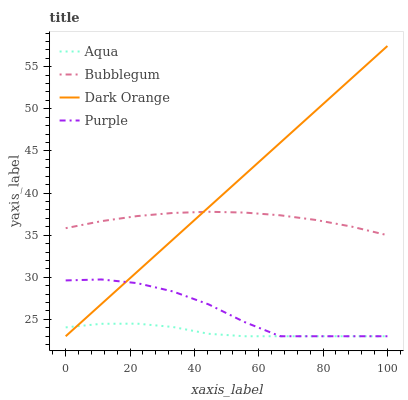Does Aqua have the minimum area under the curve?
Answer yes or no. Yes. Does Dark Orange have the maximum area under the curve?
Answer yes or no. Yes. Does Dark Orange have the minimum area under the curve?
Answer yes or no. No. Does Aqua have the maximum area under the curve?
Answer yes or no. No. Is Dark Orange the smoothest?
Answer yes or no. Yes. Is Purple the roughest?
Answer yes or no. Yes. Is Aqua the smoothest?
Answer yes or no. No. Is Aqua the roughest?
Answer yes or no. No. Does Purple have the lowest value?
Answer yes or no. Yes. Does Bubblegum have the lowest value?
Answer yes or no. No. Does Dark Orange have the highest value?
Answer yes or no. Yes. Does Aqua have the highest value?
Answer yes or no. No. Is Purple less than Bubblegum?
Answer yes or no. Yes. Is Bubblegum greater than Aqua?
Answer yes or no. Yes. Does Bubblegum intersect Dark Orange?
Answer yes or no. Yes. Is Bubblegum less than Dark Orange?
Answer yes or no. No. Is Bubblegum greater than Dark Orange?
Answer yes or no. No. Does Purple intersect Bubblegum?
Answer yes or no. No. 